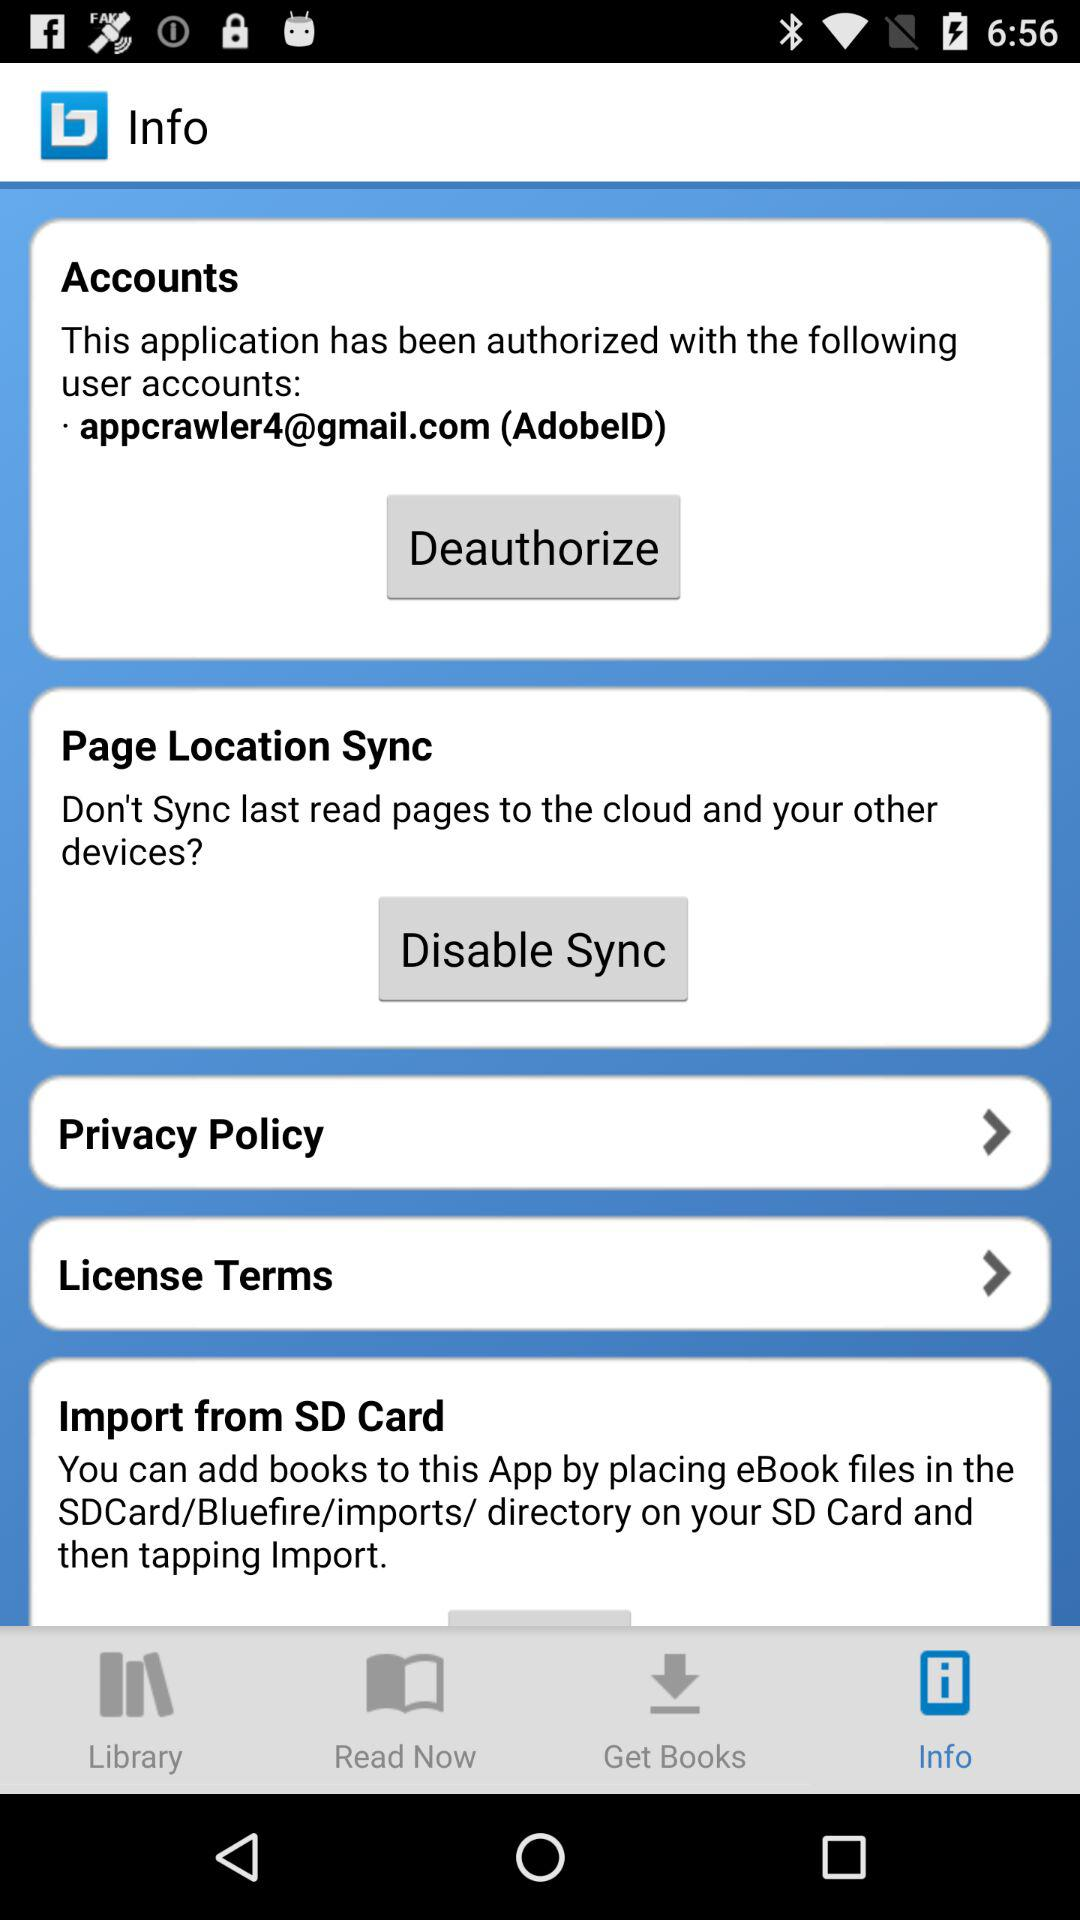Which account is used? The account used is appcrawler4@gmail.com. 